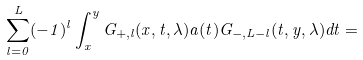Convert formula to latex. <formula><loc_0><loc_0><loc_500><loc_500>\sum _ { l = 0 } ^ { L } ( - 1 ) ^ { l } \int _ { x } ^ { y } G _ { + , l } ( x , t , \lambda ) a ( t ) G _ { - , L - l } ( t , y , \lambda ) d t =</formula> 